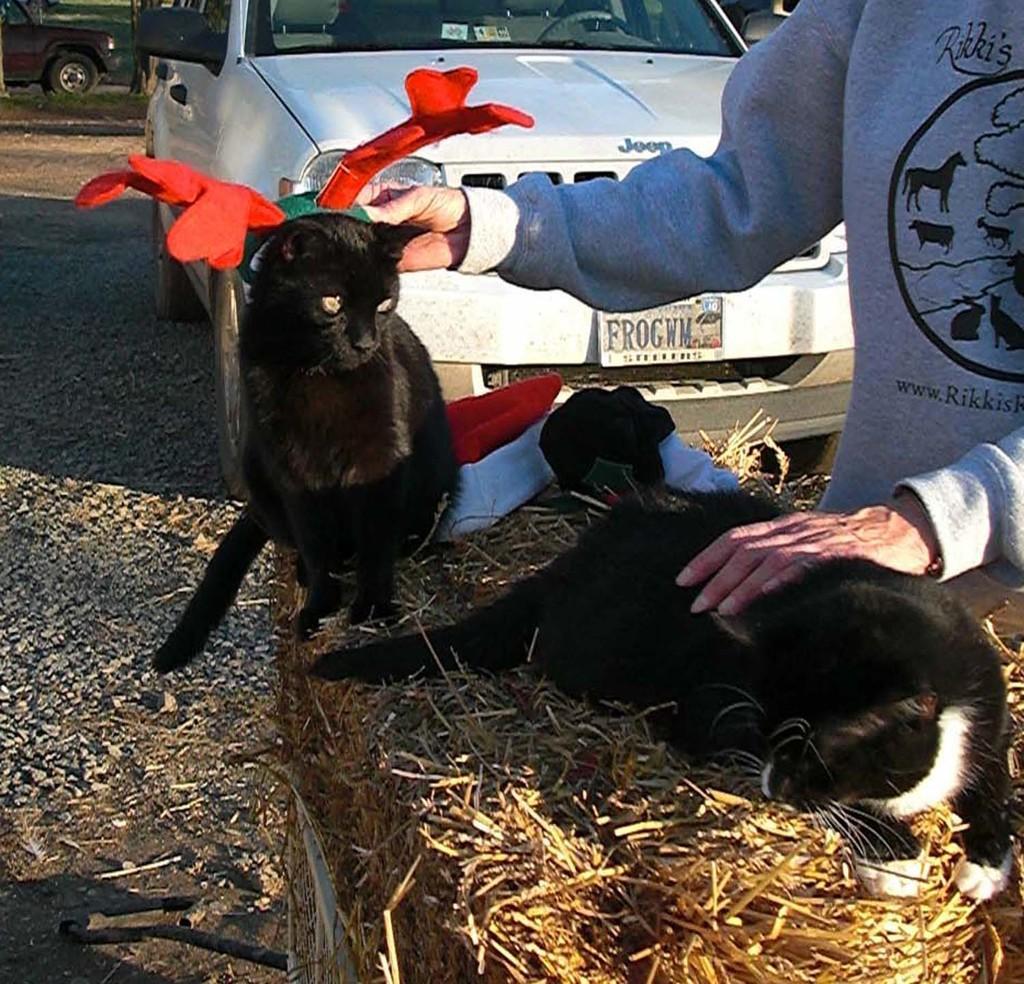Please provide a concise description of this image. In this image, we can see a person holding cats and one of them is wearing a cap and the other is lying on the dry grass. In the background, there are vehicles on the road. 